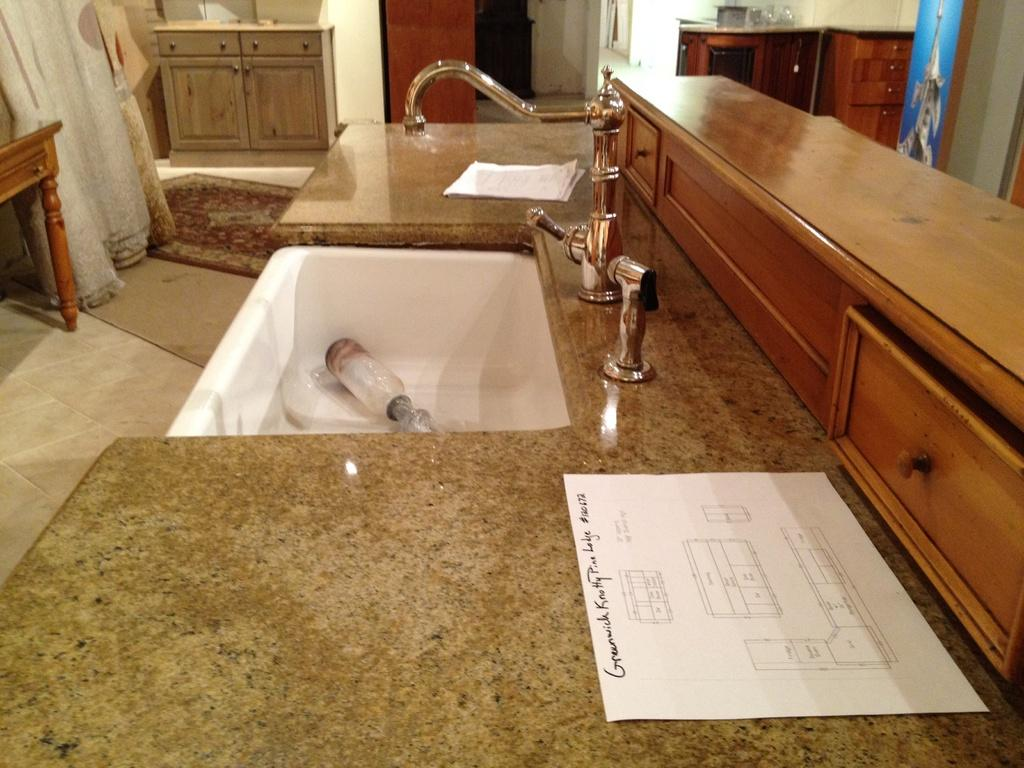What is the main object in the image? There is a wash basin in the image. What else can be seen in the image besides the wash basin? There is a paper on a table in the image. How many tomatoes are on the tramp in the image? There is no tramp or tomatoes present in the image. Is there a deer visible in the image? There is no deer present in the image. 